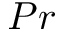<formula> <loc_0><loc_0><loc_500><loc_500>P r</formula> 